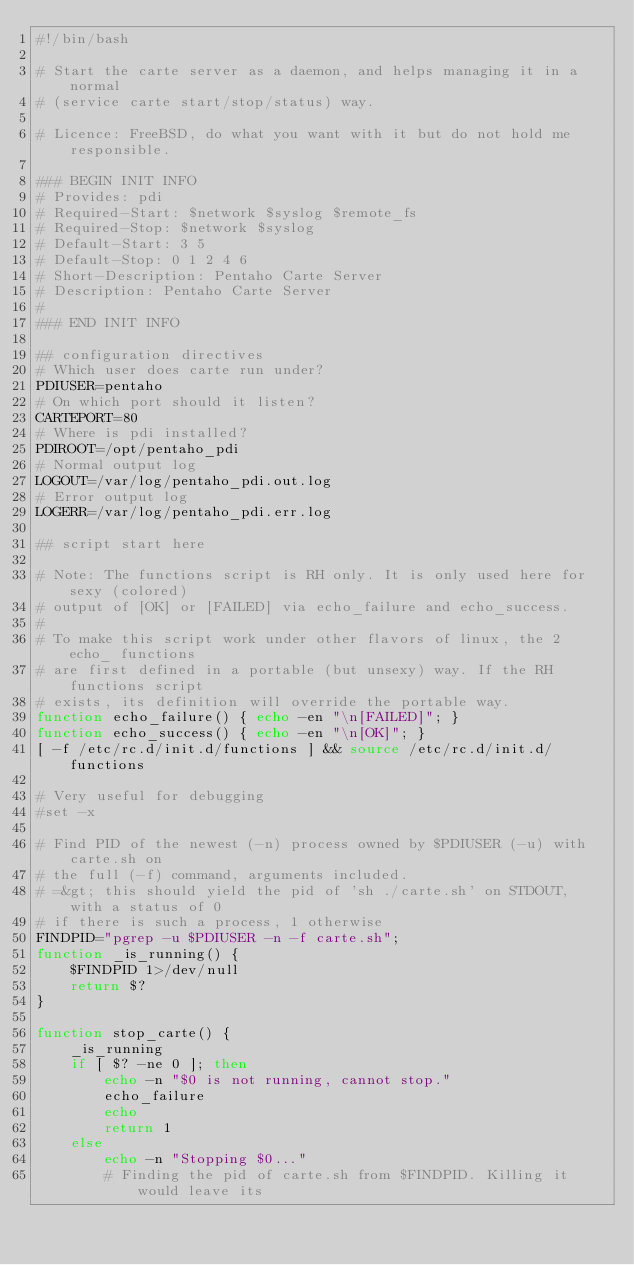Convert code to text. <code><loc_0><loc_0><loc_500><loc_500><_Bash_>#!/bin/bash

# Start the carte server as a daemon, and helps managing it in a normal
# (service carte start/stop/status) way.

# Licence: FreeBSD, do what you want with it but do not hold me responsible.

### BEGIN INIT INFO
# Provides: pdi
# Required-Start: $network $syslog $remote_fs
# Required-Stop: $network $syslog
# Default-Start: 3 5
# Default-Stop: 0 1 2 4 6
# Short-Description: Pentaho Carte Server
# Description: Pentaho Carte Server
#
### END INIT INFO

## configuration directives
# Which user does carte run under?
PDIUSER=pentaho
# On which port should it listen?
CARTEPORT=80
# Where is pdi installed?
PDIROOT=/opt/pentaho_pdi
# Normal output log
LOGOUT=/var/log/pentaho_pdi.out.log
# Error output log
LOGERR=/var/log/pentaho_pdi.err.log

## script start here

# Note: The functions script is RH only. It is only used here for sexy (colored)
# output of [OK] or [FAILED] via echo_failure and echo_success.
#
# To make this script work under other flavors of linux, the 2 echo_ functions
# are first defined in a portable (but unsexy) way. If the RH functions script
# exists, its definition will override the portable way.
function echo_failure() { echo -en "\n[FAILED]"; }
function echo_success() { echo -en "\n[OK]"; }
[ -f /etc/rc.d/init.d/functions ] && source /etc/rc.d/init.d/functions

# Very useful for debugging
#set -x

# Find PID of the newest (-n) process owned by $PDIUSER (-u) with carte.sh on
# the full (-f) command, arguments included.
# =&gt; this should yield the pid of 'sh ./carte.sh' on STDOUT, with a status of 0
# if there is such a process, 1 otherwise
FINDPID="pgrep -u $PDIUSER -n -f carte.sh";
function _is_running() {
    $FINDPID 1>/dev/null
    return $?
}

function stop_carte() {
    _is_running
    if [ $? -ne 0 ]; then
        echo -n "$0 is not running, cannot stop."
        echo_failure
        echo
        return 1
    else
        echo -n "Stopping $0..."
        # Finding the pid of carte.sh from $FINDPID. Killing it would leave its</code> 